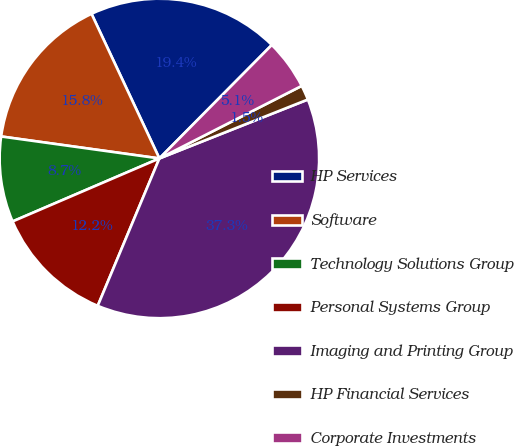<chart> <loc_0><loc_0><loc_500><loc_500><pie_chart><fcel>HP Services<fcel>Software<fcel>Technology Solutions Group<fcel>Personal Systems Group<fcel>Imaging and Printing Group<fcel>HP Financial Services<fcel>Corporate Investments<nl><fcel>19.41%<fcel>15.82%<fcel>8.65%<fcel>12.24%<fcel>37.32%<fcel>1.49%<fcel>5.07%<nl></chart> 